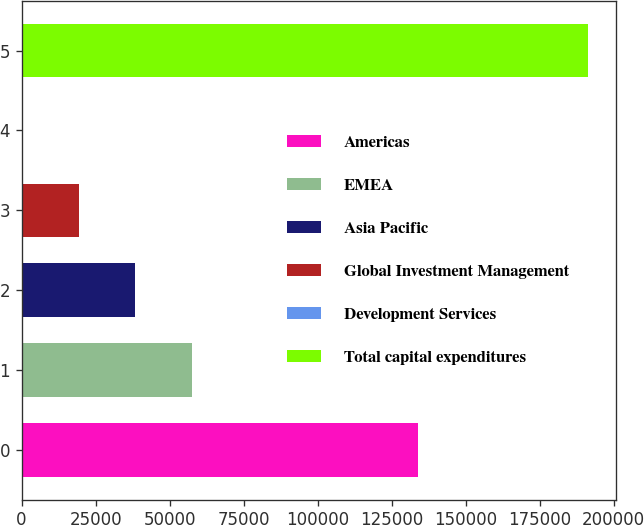<chart> <loc_0><loc_0><loc_500><loc_500><bar_chart><fcel>Americas<fcel>EMEA<fcel>Asia Pacific<fcel>Global Investment Management<fcel>Development Services<fcel>Total capital expenditures<nl><fcel>134046<fcel>57540<fcel>38445<fcel>19350<fcel>255<fcel>191205<nl></chart> 